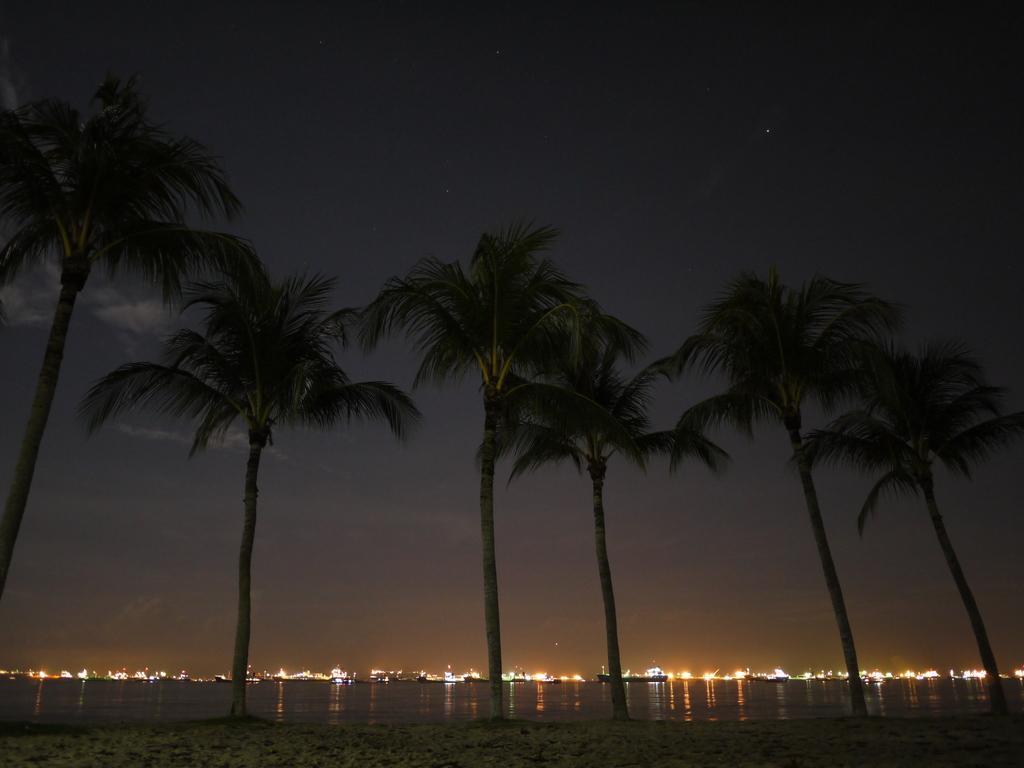Describe this image in one or two sentences. In the center of the image there are trees. There is water. At the bottom of the image there is sand. In the background of the image there are lights. There is sky. 